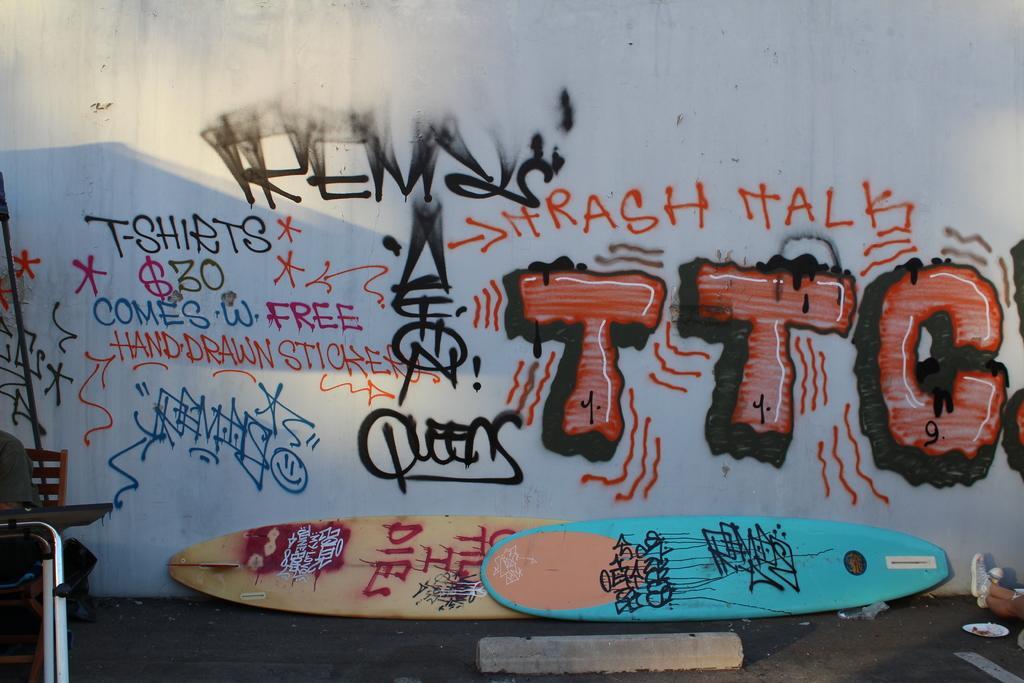Can you describe this image briefly? In this picture I can observe some text painted on the wall. I can observe red, black, pink and blue colors on the wall. I can observe surfing boards which are in blue and yellow colors placed on the land. 